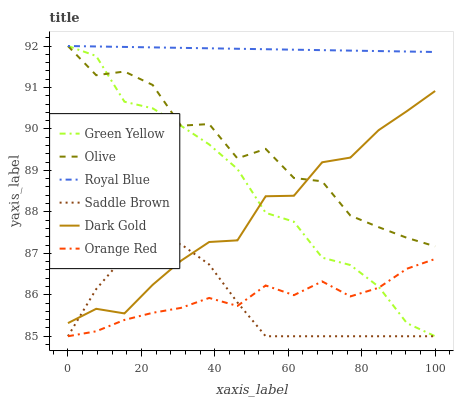Does Saddle Brown have the minimum area under the curve?
Answer yes or no. Yes. Does Royal Blue have the maximum area under the curve?
Answer yes or no. Yes. Does Orange Red have the minimum area under the curve?
Answer yes or no. No. Does Orange Red have the maximum area under the curve?
Answer yes or no. No. Is Royal Blue the smoothest?
Answer yes or no. Yes. Is Olive the roughest?
Answer yes or no. Yes. Is Orange Red the smoothest?
Answer yes or no. No. Is Orange Red the roughest?
Answer yes or no. No. Does Orange Red have the lowest value?
Answer yes or no. Yes. Does Royal Blue have the lowest value?
Answer yes or no. No. Does Green Yellow have the highest value?
Answer yes or no. Yes. Does Orange Red have the highest value?
Answer yes or no. No. Is Orange Red less than Dark Gold?
Answer yes or no. Yes. Is Royal Blue greater than Orange Red?
Answer yes or no. Yes. Does Orange Red intersect Saddle Brown?
Answer yes or no. Yes. Is Orange Red less than Saddle Brown?
Answer yes or no. No. Is Orange Red greater than Saddle Brown?
Answer yes or no. No. Does Orange Red intersect Dark Gold?
Answer yes or no. No. 